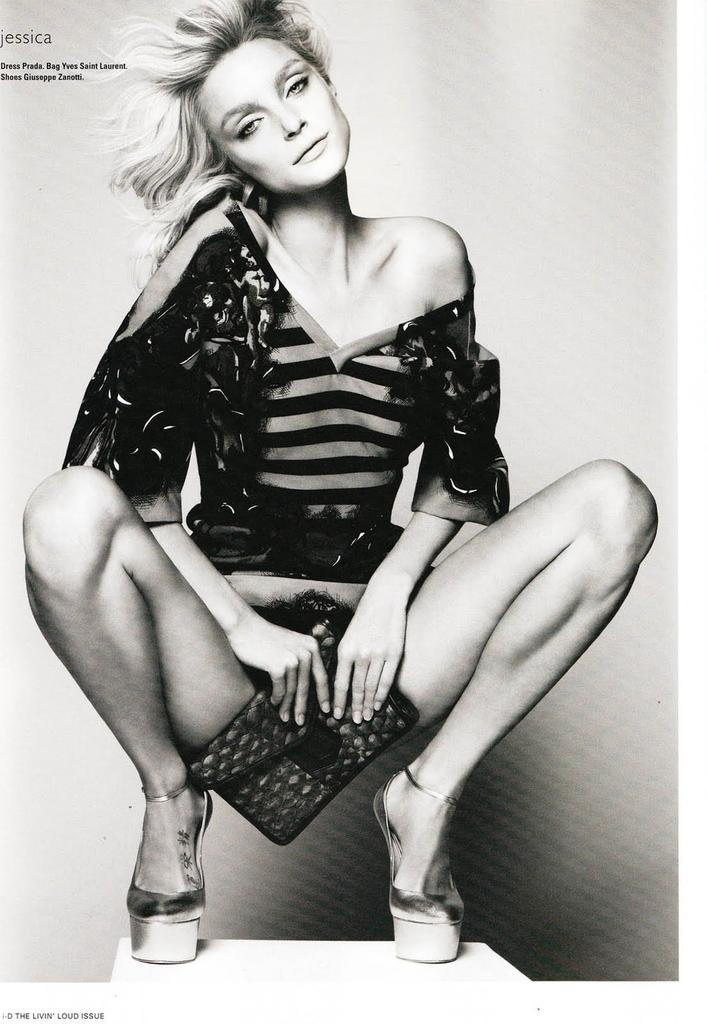What is the color scheme of the image? The image is black and white. Who is present in the image? There is a woman in the image. What is the woman holding in the image? The woman is holding a clutch. What is the woman doing in the image? The woman is watching something. Where can text be found in the image? There is text on the left side of the image. How many legs can be seen on the truck in the image? There is no truck present in the image, so it is not possible to determine the number of legs on a truck. 